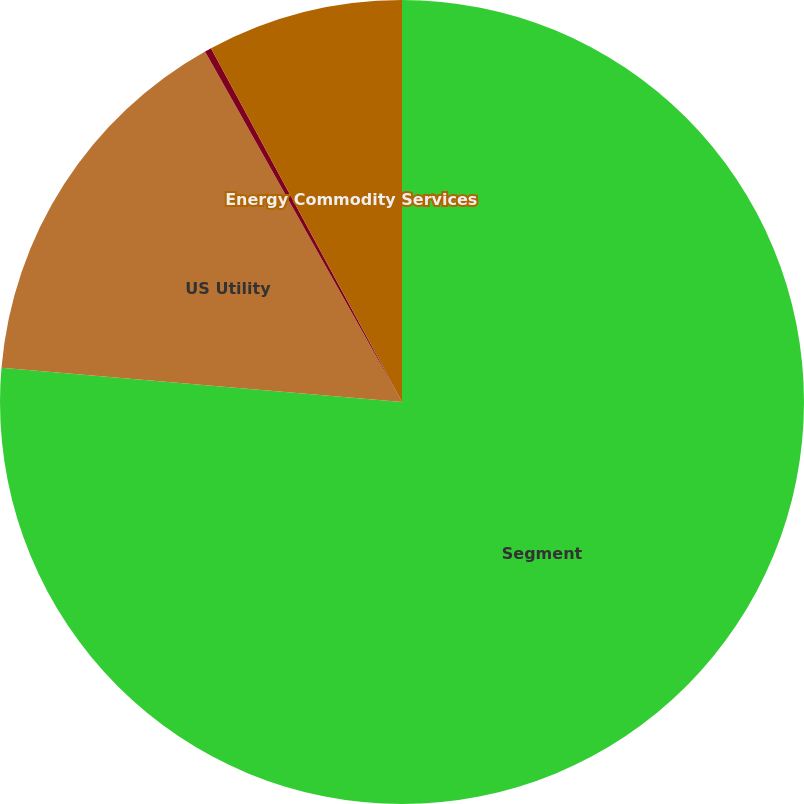<chart> <loc_0><loc_0><loc_500><loc_500><pie_chart><fcel>Segment<fcel>US Utility<fcel>Non-Utility Nuclear<fcel>Energy Commodity Services<nl><fcel>76.37%<fcel>15.49%<fcel>0.27%<fcel>7.88%<nl></chart> 